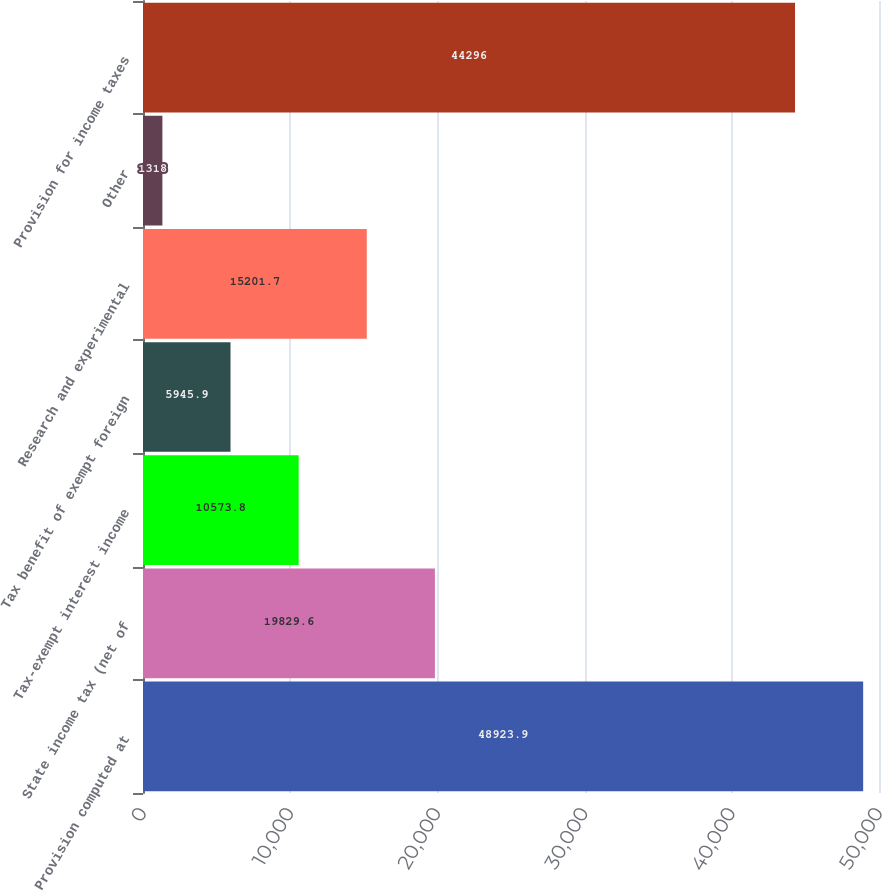Convert chart to OTSL. <chart><loc_0><loc_0><loc_500><loc_500><bar_chart><fcel>Provision computed at<fcel>State income tax (net of<fcel>Tax-exempt interest income<fcel>Tax benefit of exempt foreign<fcel>Research and experimental<fcel>Other<fcel>Provision for income taxes<nl><fcel>48923.9<fcel>19829.6<fcel>10573.8<fcel>5945.9<fcel>15201.7<fcel>1318<fcel>44296<nl></chart> 